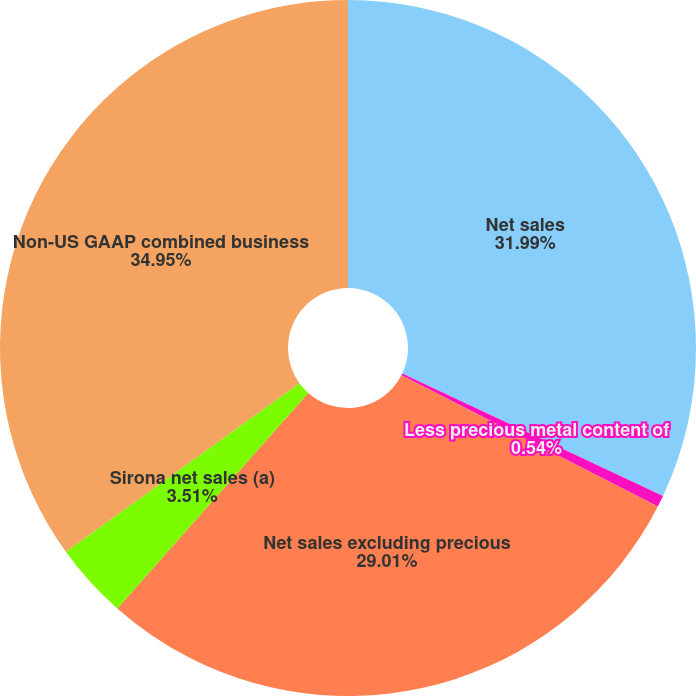Convert chart to OTSL. <chart><loc_0><loc_0><loc_500><loc_500><pie_chart><fcel>Net sales<fcel>Less precious metal content of<fcel>Net sales excluding precious<fcel>Sirona net sales (a)<fcel>Non-US GAAP combined business<nl><fcel>31.99%<fcel>0.54%<fcel>29.01%<fcel>3.51%<fcel>34.96%<nl></chart> 